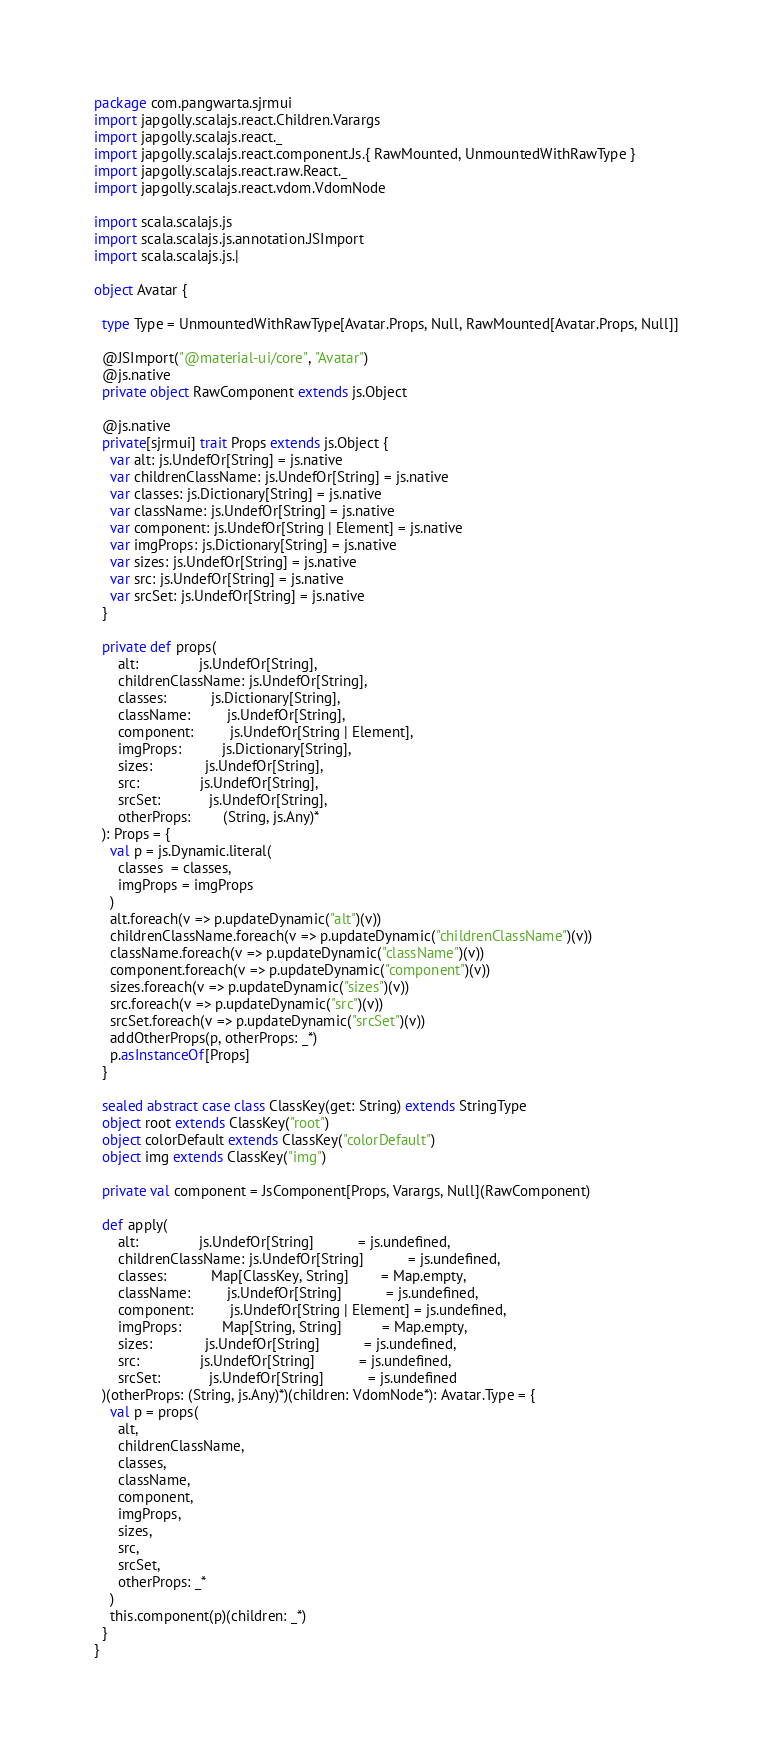<code> <loc_0><loc_0><loc_500><loc_500><_Scala_>package com.pangwarta.sjrmui
import japgolly.scalajs.react.Children.Varargs
import japgolly.scalajs.react._
import japgolly.scalajs.react.component.Js.{ RawMounted, UnmountedWithRawType }
import japgolly.scalajs.react.raw.React._
import japgolly.scalajs.react.vdom.VdomNode

import scala.scalajs.js
import scala.scalajs.js.annotation.JSImport
import scala.scalajs.js.|

object Avatar {

  type Type = UnmountedWithRawType[Avatar.Props, Null, RawMounted[Avatar.Props, Null]]

  @JSImport("@material-ui/core", "Avatar")
  @js.native
  private object RawComponent extends js.Object

  @js.native
  private[sjrmui] trait Props extends js.Object {
    var alt: js.UndefOr[String] = js.native
    var childrenClassName: js.UndefOr[String] = js.native
    var classes: js.Dictionary[String] = js.native
    var className: js.UndefOr[String] = js.native
    var component: js.UndefOr[String | Element] = js.native
    var imgProps: js.Dictionary[String] = js.native
    var sizes: js.UndefOr[String] = js.native
    var src: js.UndefOr[String] = js.native
    var srcSet: js.UndefOr[String] = js.native
  }

  private def props(
      alt:               js.UndefOr[String],
      childrenClassName: js.UndefOr[String],
      classes:           js.Dictionary[String],
      className:         js.UndefOr[String],
      component:         js.UndefOr[String | Element],
      imgProps:          js.Dictionary[String],
      sizes:             js.UndefOr[String],
      src:               js.UndefOr[String],
      srcSet:            js.UndefOr[String],
      otherProps:        (String, js.Any)*
  ): Props = {
    val p = js.Dynamic.literal(
      classes  = classes,
      imgProps = imgProps
    )
    alt.foreach(v => p.updateDynamic("alt")(v))
    childrenClassName.foreach(v => p.updateDynamic("childrenClassName")(v))
    className.foreach(v => p.updateDynamic("className")(v))
    component.foreach(v => p.updateDynamic("component")(v))
    sizes.foreach(v => p.updateDynamic("sizes")(v))
    src.foreach(v => p.updateDynamic("src")(v))
    srcSet.foreach(v => p.updateDynamic("srcSet")(v))
    addOtherProps(p, otherProps: _*)
    p.asInstanceOf[Props]
  }

  sealed abstract case class ClassKey(get: String) extends StringType
  object root extends ClassKey("root")
  object colorDefault extends ClassKey("colorDefault")
  object img extends ClassKey("img")

  private val component = JsComponent[Props, Varargs, Null](RawComponent)

  def apply(
      alt:               js.UndefOr[String]           = js.undefined,
      childrenClassName: js.UndefOr[String]           = js.undefined,
      classes:           Map[ClassKey, String]        = Map.empty,
      className:         js.UndefOr[String]           = js.undefined,
      component:         js.UndefOr[String | Element] = js.undefined,
      imgProps:          Map[String, String]          = Map.empty,
      sizes:             js.UndefOr[String]           = js.undefined,
      src:               js.UndefOr[String]           = js.undefined,
      srcSet:            js.UndefOr[String]           = js.undefined
  )(otherProps: (String, js.Any)*)(children: VdomNode*): Avatar.Type = {
    val p = props(
      alt,
      childrenClassName,
      classes,
      className,
      component,
      imgProps,
      sizes,
      src,
      srcSet,
      otherProps: _*
    )
    this.component(p)(children: _*)
  }
}
</code> 